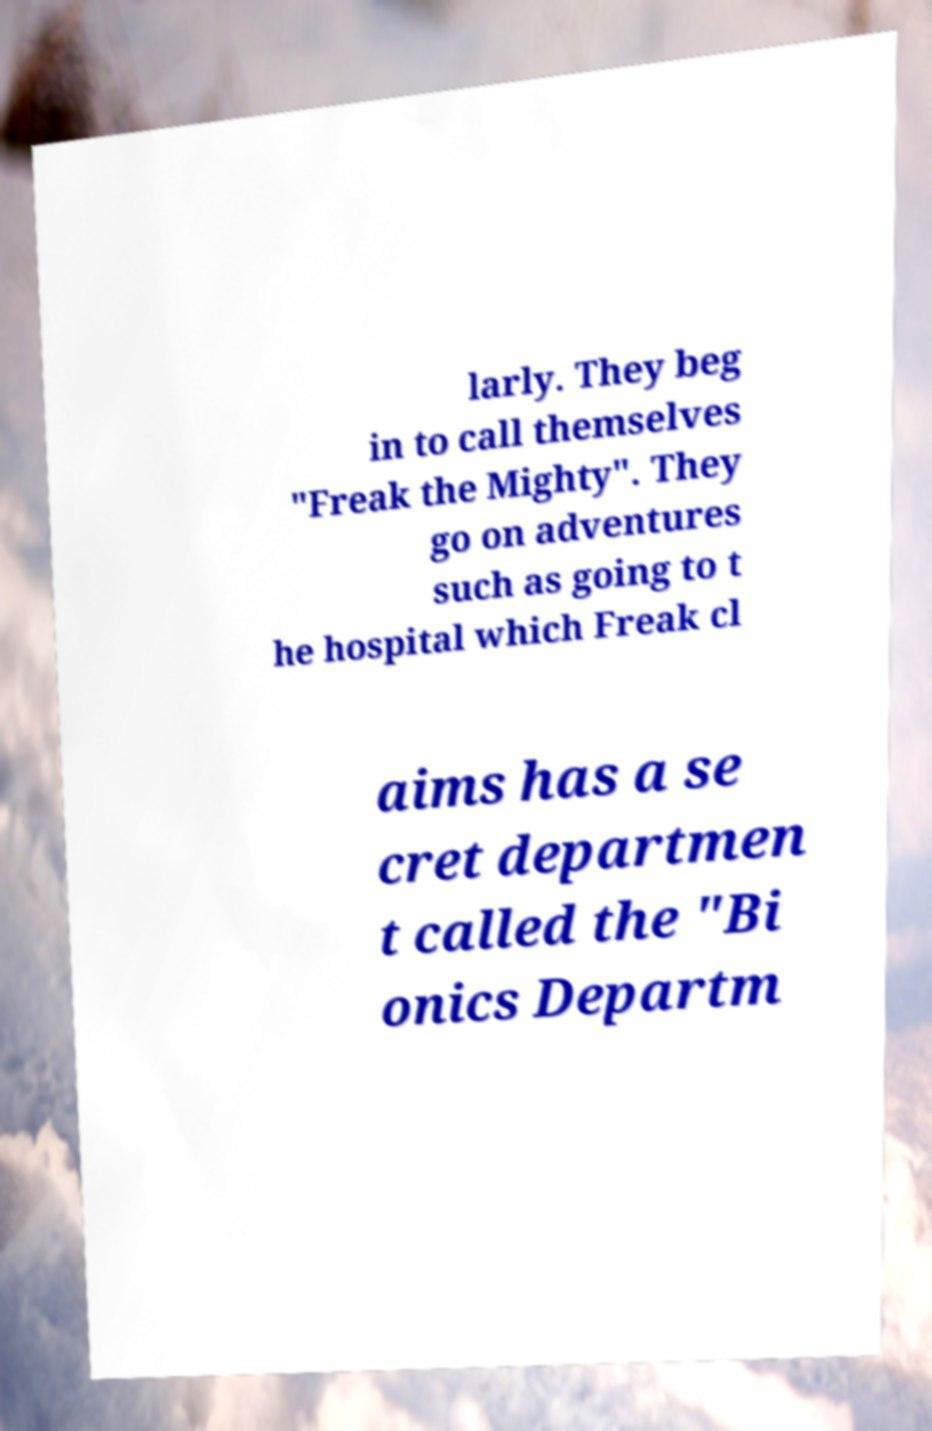For documentation purposes, I need the text within this image transcribed. Could you provide that? larly. They beg in to call themselves "Freak the Mighty". They go on adventures such as going to t he hospital which Freak cl aims has a se cret departmen t called the "Bi onics Departm 